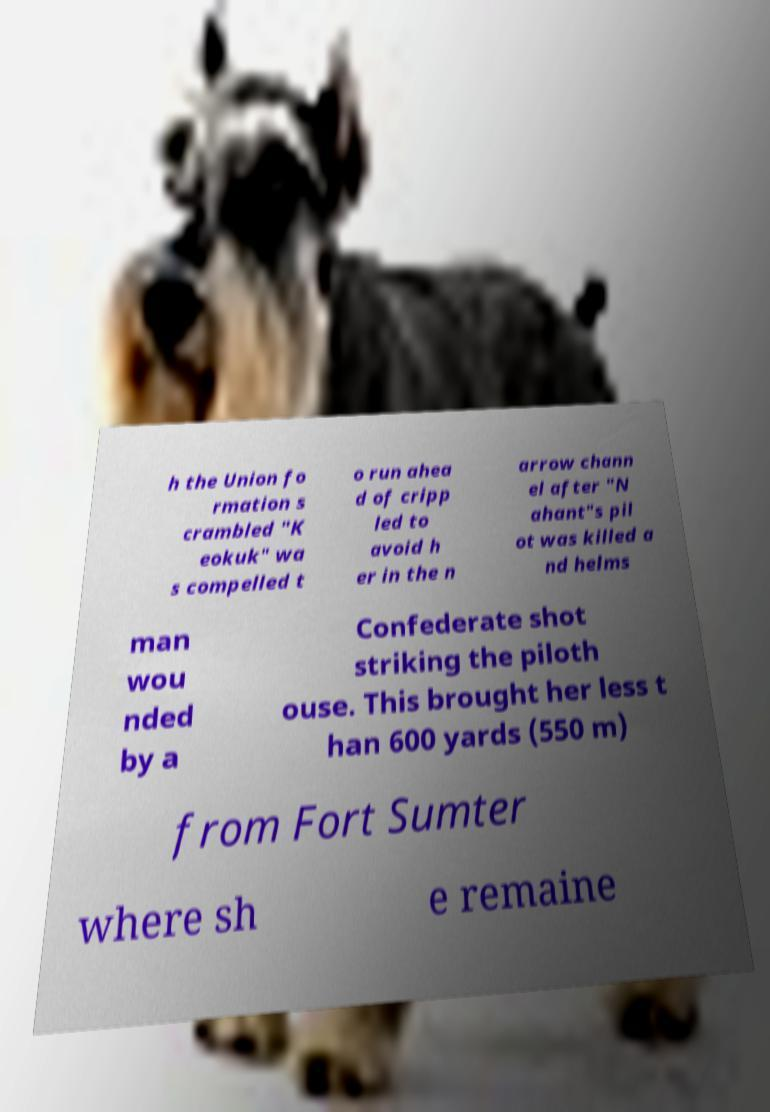Please read and relay the text visible in this image. What does it say? h the Union fo rmation s crambled "K eokuk" wa s compelled t o run ahea d of cripp led to avoid h er in the n arrow chann el after "N ahant"s pil ot was killed a nd helms man wou nded by a Confederate shot striking the piloth ouse. This brought her less t han 600 yards (550 m) from Fort Sumter where sh e remaine 